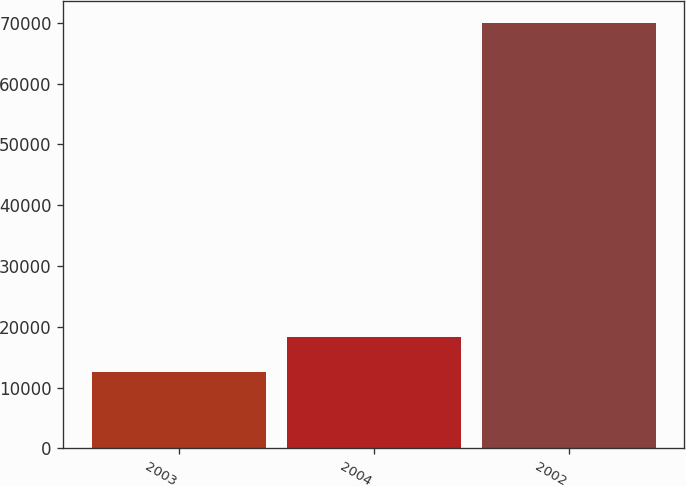Convert chart. <chart><loc_0><loc_0><loc_500><loc_500><bar_chart><fcel>2003<fcel>2004<fcel>2002<nl><fcel>12535<fcel>18285.8<fcel>70043<nl></chart> 